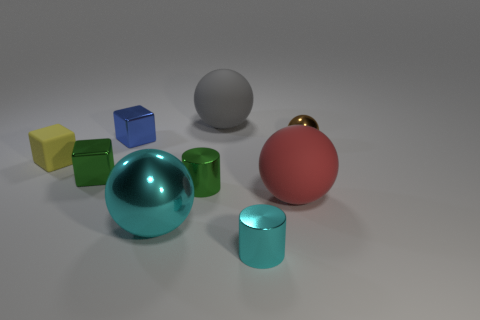There is a cylinder that is the same color as the big metallic sphere; what material is it?
Give a very brief answer. Metal. What size is the cylinder that is the same color as the big shiny thing?
Offer a terse response. Small. What number of other objects are the same shape as the big cyan object?
Your response must be concise. 3. Is the number of metallic spheres that are to the right of the red matte sphere less than the number of tiny brown things that are on the left side of the blue thing?
Keep it short and to the point. No. Do the gray thing and the tiny object that is in front of the big red matte object have the same material?
Make the answer very short. No. Is there anything else that has the same material as the blue cube?
Provide a short and direct response. Yes. Are there more large brown things than green shiny cylinders?
Give a very brief answer. No. What is the shape of the big matte object that is in front of the sphere right of the large matte sphere in front of the rubber block?
Keep it short and to the point. Sphere. Does the cylinder that is to the left of the tiny cyan metal cylinder have the same material as the tiny block right of the tiny green block?
Give a very brief answer. Yes. The brown object that is the same material as the big cyan thing is what shape?
Ensure brevity in your answer.  Sphere. 